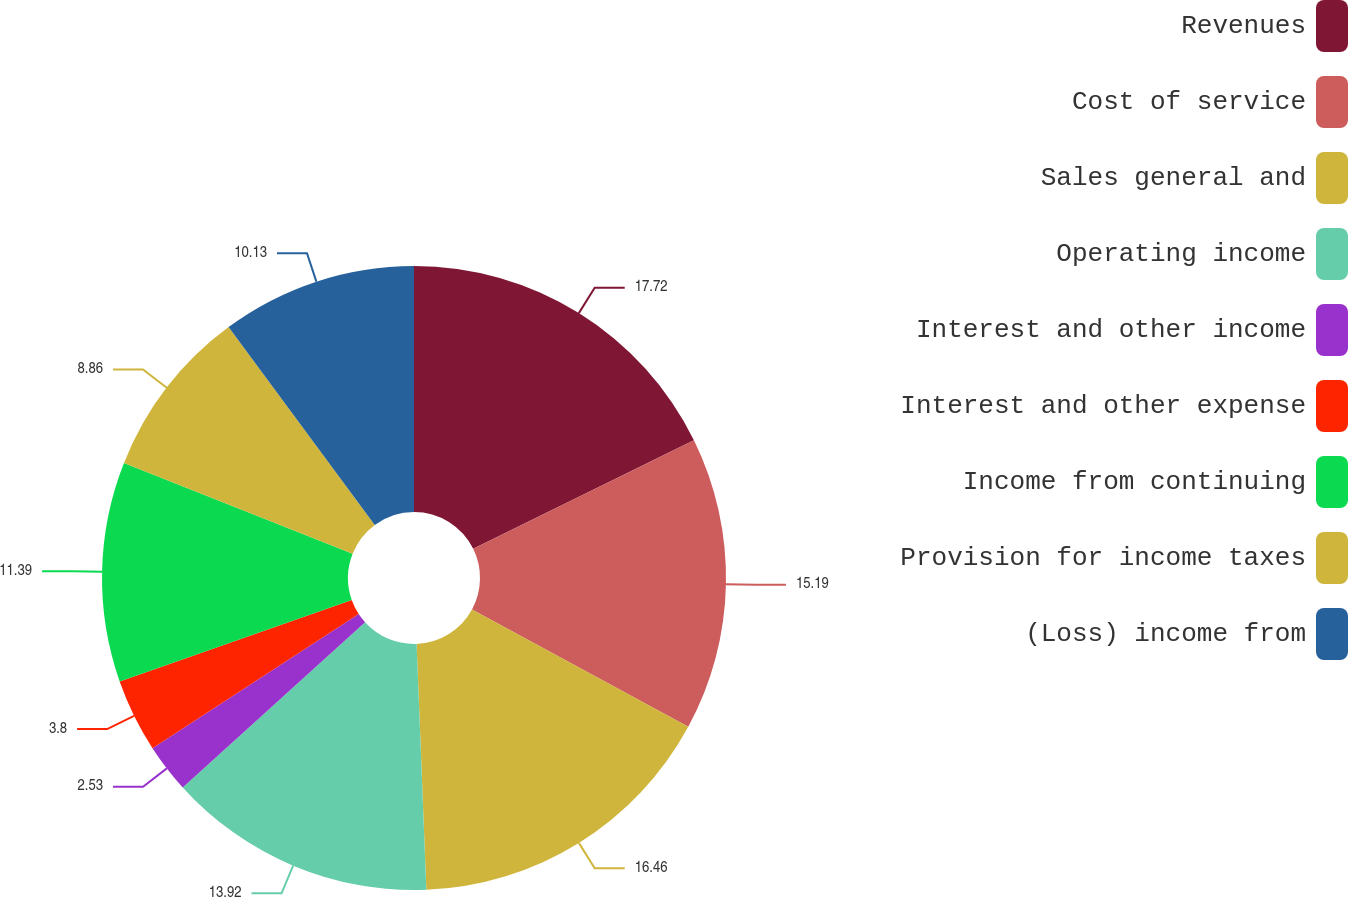<chart> <loc_0><loc_0><loc_500><loc_500><pie_chart><fcel>Revenues<fcel>Cost of service<fcel>Sales general and<fcel>Operating income<fcel>Interest and other income<fcel>Interest and other expense<fcel>Income from continuing<fcel>Provision for income taxes<fcel>(Loss) income from<nl><fcel>17.72%<fcel>15.19%<fcel>16.46%<fcel>13.92%<fcel>2.53%<fcel>3.8%<fcel>11.39%<fcel>8.86%<fcel>10.13%<nl></chart> 